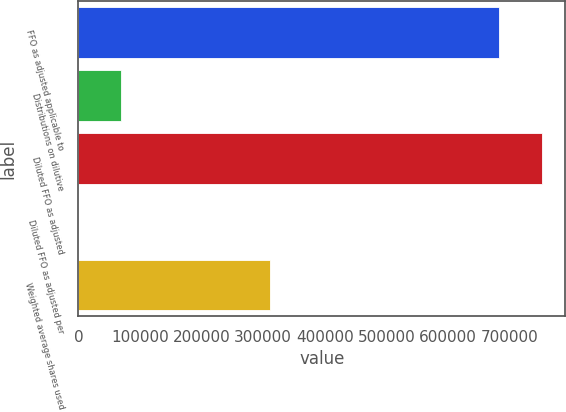<chart> <loc_0><loc_0><loc_500><loc_500><bar_chart><fcel>FFO as adjusted applicable to<fcel>Distributions on dilutive<fcel>Diluted FFO as adjusted<fcel>Diluted FFO as adjusted per<fcel>Weighted average shares used<nl><fcel>683076<fcel>69518.5<fcel>752592<fcel>2.23<fcel>311285<nl></chart> 